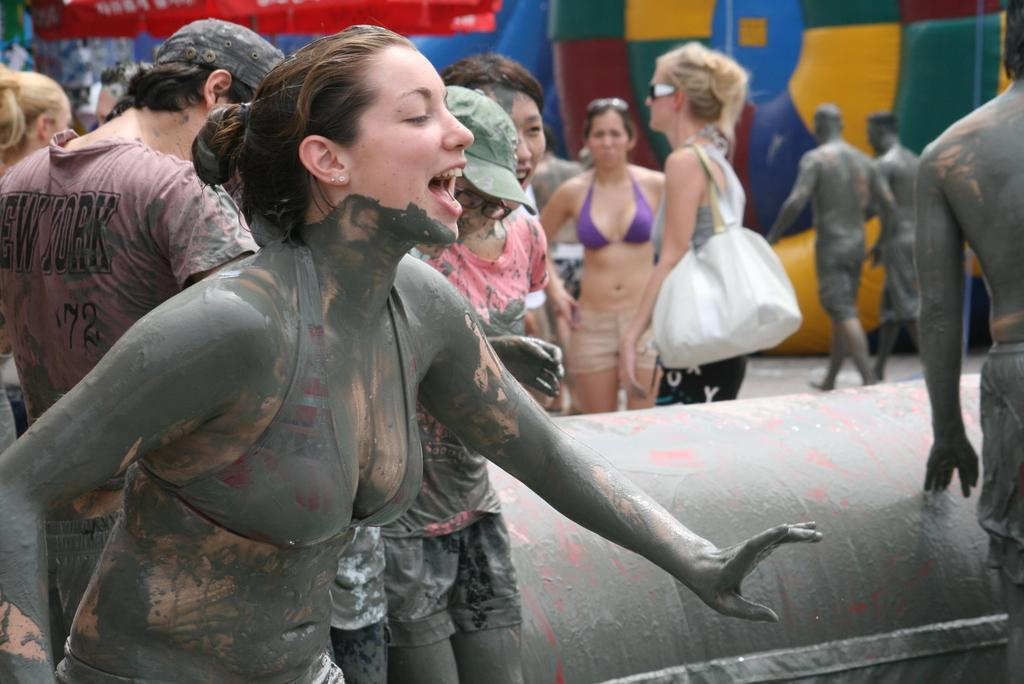What is the location of the woman in the image? The woman is on the left side of the image. What is the condition of the woman's body? The woman has mud on her body. What is the woman doing in the image? The woman is speaking. Can you describe the background of the image? There are other persons in the background of the image, and there is mud on an object. What type of account does the woman have with the roof in the image? There is no mention of an account or a roof in the image; it features a woman with mud on her body who is speaking. 